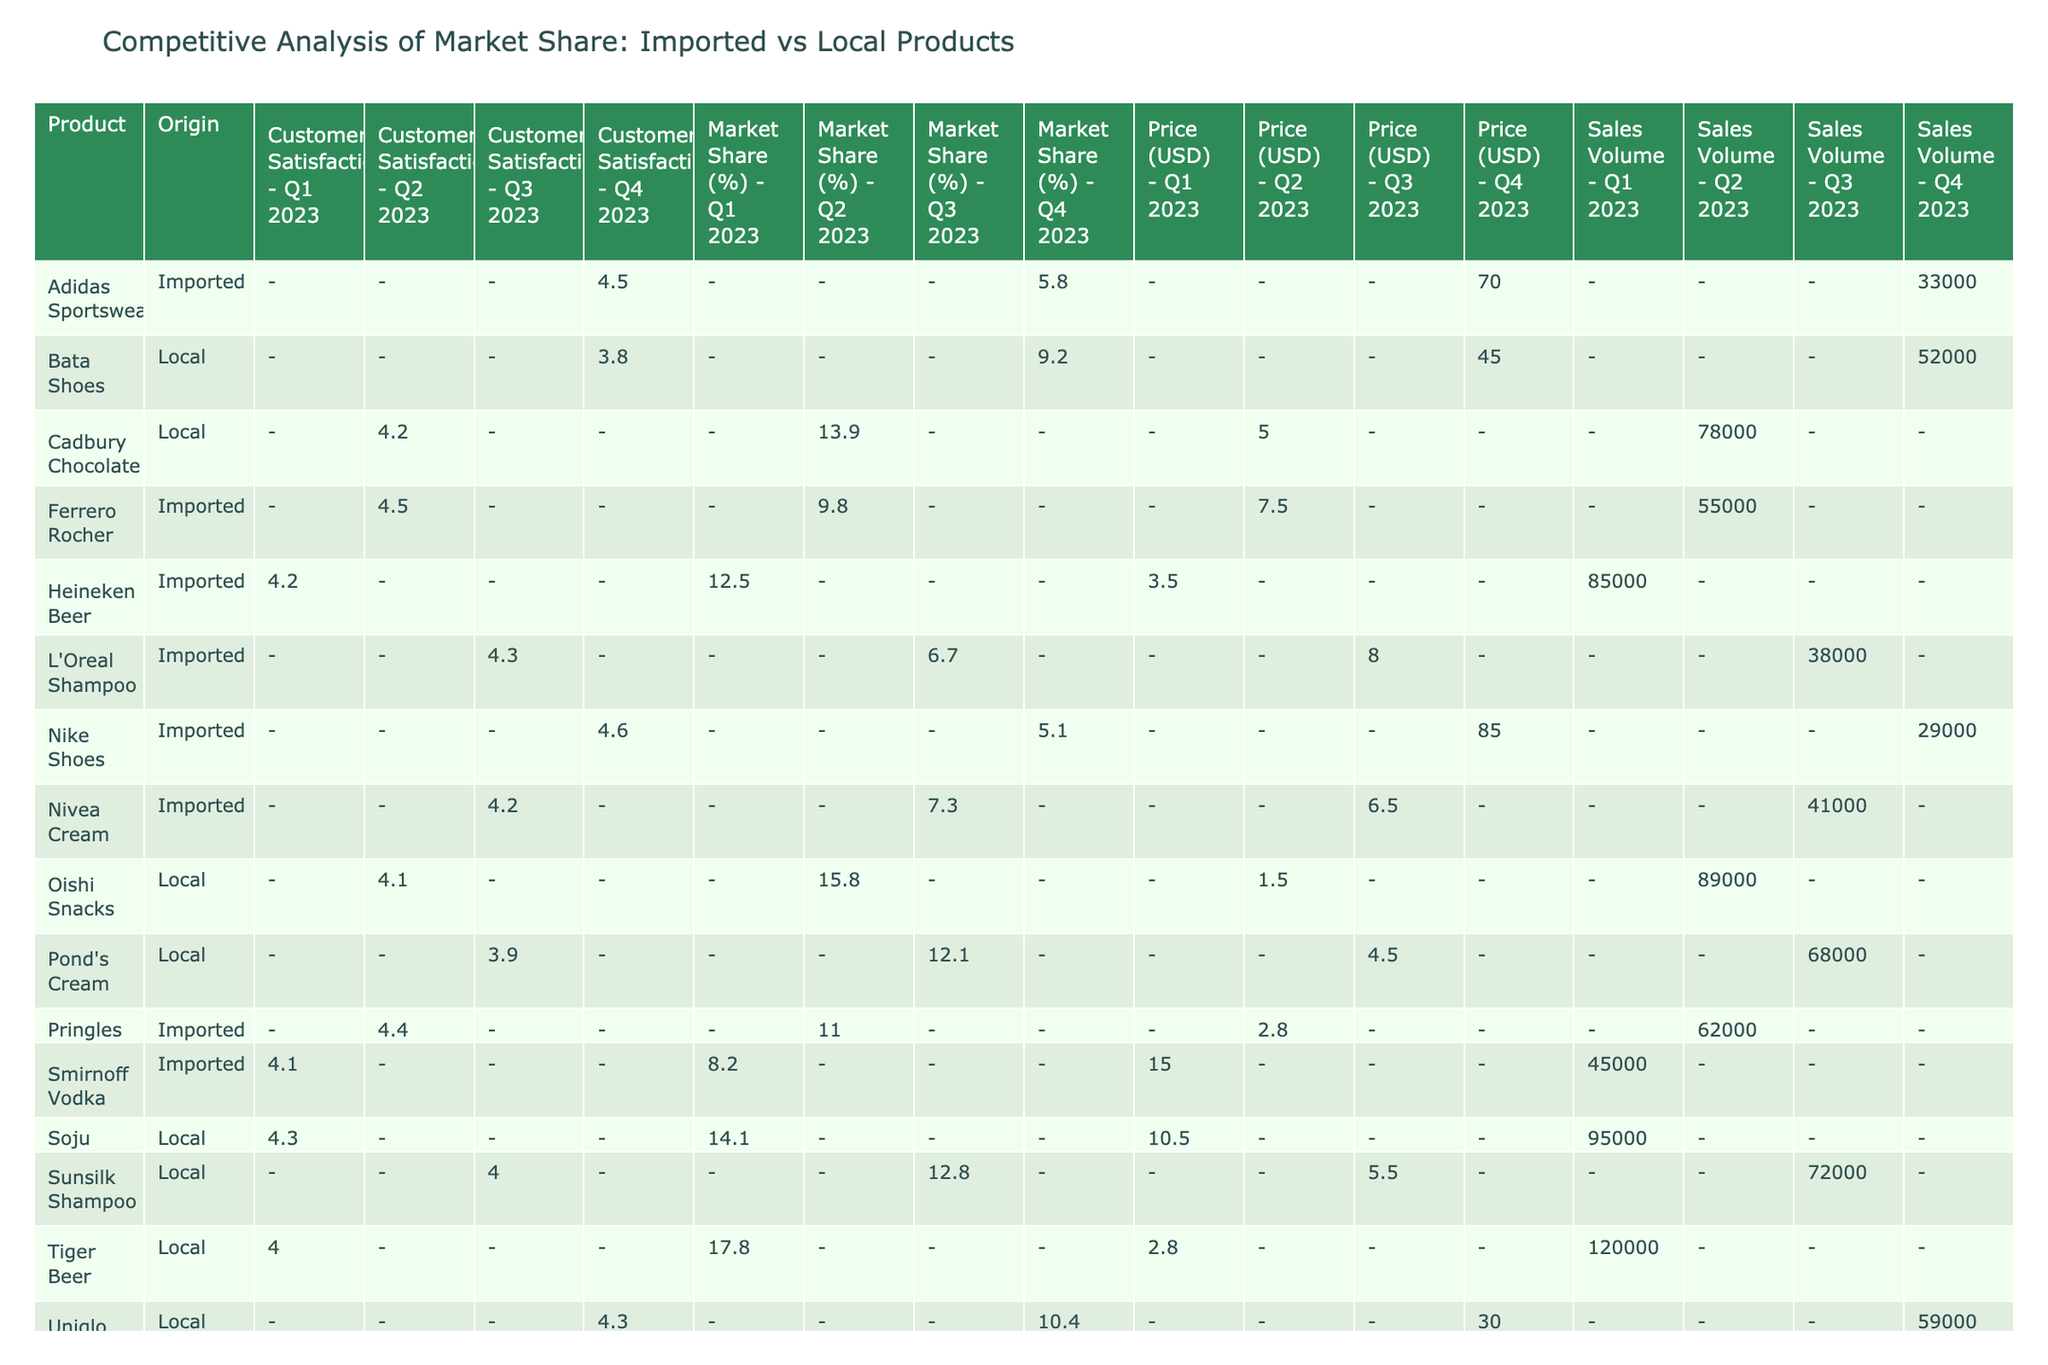What is the market share of Heineken Beer in Q1 2023? The market share column under Q1 2023 for Heineken Beer shows 12.5%.
Answer: 12.5% Which product had the highest sales volume in Q2 2023? Looking at the sales volume in Q2 2023, Cadbury Chocolate had the highest value with 78,000 units sold.
Answer: Cadbury Chocolate Is the price of Smirnoff Vodka higher than the price of Soju in Q1 2023? The price for Smirnoff Vodka is 15.00 USD and for Soju, it is 10.50 USD. Since 15.00 is greater than 10.50, the answer is yes.
Answer: Yes What is the average market share of imported products in Q4 2023? The imported products in Q4 2023 are Nike Shoes (5.1%) and Adidas Sportswear (5.8%). The average market share is (5.1 + 5.8) / 2 = 5.45%.
Answer: 5.45% Did local products ever surpass imported products in sales volume in any quarter? In Q1 2023, local products (Tiger Beer and Soju) had combined sales of 212,000 units, while imported products (Heineken Beer and Smirnoff Vodka) only totaled 130,000 units. Local products surpassed imported in Q1 2023.
Answer: Yes Which shampoo had a higher customer satisfaction rating, L’Oreal Shampoo or Sunsilk Shampoo? L’Oreal Shampoo has a customer satisfaction of 4.3, while Sunsilk Shampoo has 4.0. Since 4.3 is greater than 4.0, L’Oreal Shampoo has the higher rating.
Answer: L’Oreal Shampoo During which quarter did the local product Oishi Snacks achieve its peak market share? Oishi Snacks is listed under Q2 2023 with a market share of 15.8%, which is their peak when compared to 12.1% in Q3 2023 and no data for other quarters.
Answer: Q2 2023 What is the difference in customer satisfaction between the highest and lowest-rated products across all quarters? The highest customer satisfaction is 4.6 (Nike Shoes), and the lowest is 3.8 (Bata Shoes). The difference is 4.6 - 3.8 = 0.8.
Answer: 0.8 In Q3 2023, what percentage of the total market share did local products hold when combined? Adding local products' market shares in Q3 2023: Sunsilk Shampoo (12.8%) and Pond's Cream (12.1%), gives 12.8 + 12.1 = 24.9%.
Answer: 24.9% 